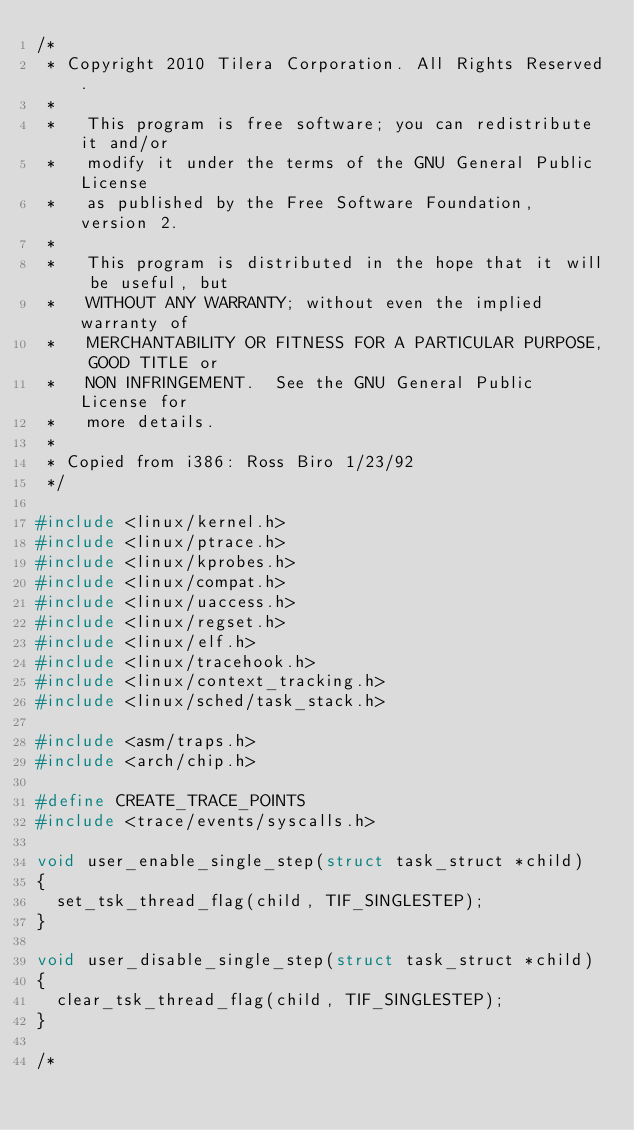Convert code to text. <code><loc_0><loc_0><loc_500><loc_500><_C_>/*
 * Copyright 2010 Tilera Corporation. All Rights Reserved.
 *
 *   This program is free software; you can redistribute it and/or
 *   modify it under the terms of the GNU General Public License
 *   as published by the Free Software Foundation, version 2.
 *
 *   This program is distributed in the hope that it will be useful, but
 *   WITHOUT ANY WARRANTY; without even the implied warranty of
 *   MERCHANTABILITY OR FITNESS FOR A PARTICULAR PURPOSE, GOOD TITLE or
 *   NON INFRINGEMENT.  See the GNU General Public License for
 *   more details.
 *
 * Copied from i386: Ross Biro 1/23/92
 */

#include <linux/kernel.h>
#include <linux/ptrace.h>
#include <linux/kprobes.h>
#include <linux/compat.h>
#include <linux/uaccess.h>
#include <linux/regset.h>
#include <linux/elf.h>
#include <linux/tracehook.h>
#include <linux/context_tracking.h>
#include <linux/sched/task_stack.h>

#include <asm/traps.h>
#include <arch/chip.h>

#define CREATE_TRACE_POINTS
#include <trace/events/syscalls.h>

void user_enable_single_step(struct task_struct *child)
{
	set_tsk_thread_flag(child, TIF_SINGLESTEP);
}

void user_disable_single_step(struct task_struct *child)
{
	clear_tsk_thread_flag(child, TIF_SINGLESTEP);
}

/*</code> 